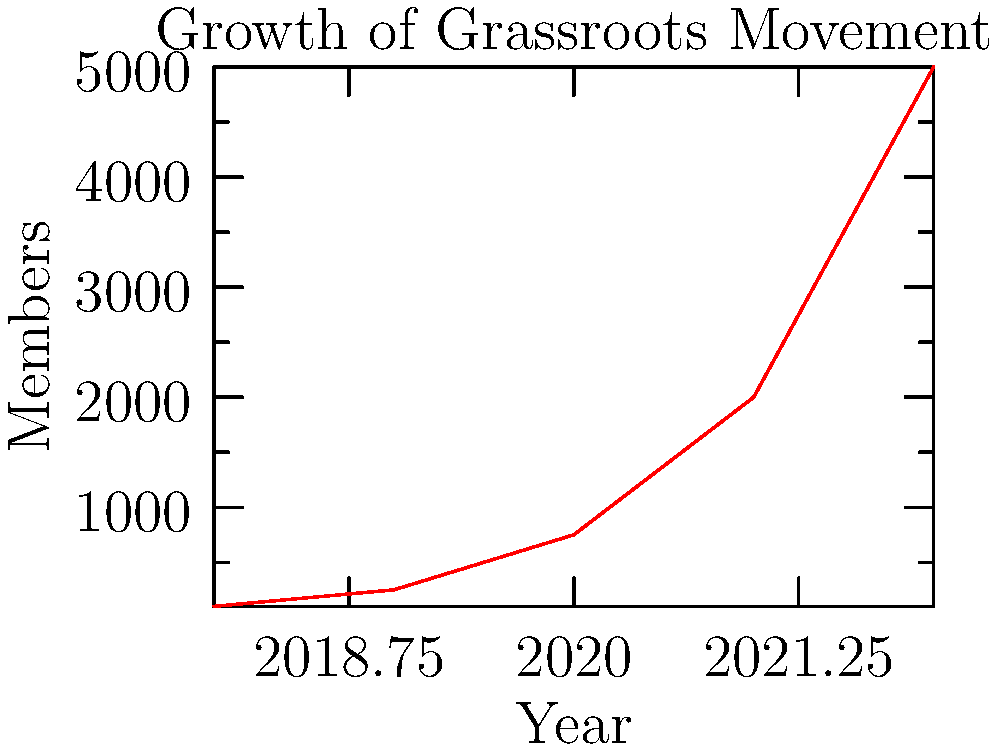Analyze the growth trend of the grassroots movement shown in the line graph. What type of growth does this movement exhibit, and in which year did the most significant increase in membership occur? To analyze the growth trend and identify the year with the most significant increase, we need to follow these steps:

1. Observe the overall shape of the line: The curve is steepening over time, indicating accelerating growth.

2. Calculate the year-over-year growth:
   2018 to 2019: 250 - 100 = 150 new members
   2019 to 2020: 750 - 250 = 500 new members
   2020 to 2021: 2000 - 750 = 1250 new members
   2021 to 2022: 5000 - 2000 = 3000 new members

3. Compare the increases:
   The largest increase occurred between 2021 and 2022 with 3000 new members.

4. Identify the growth type:
   The increasing rate of growth each year indicates exponential growth.

Therefore, the movement exhibits exponential growth, with the most significant increase in membership occurring between 2021 and 2022.
Answer: Exponential growth; 2021-2022 